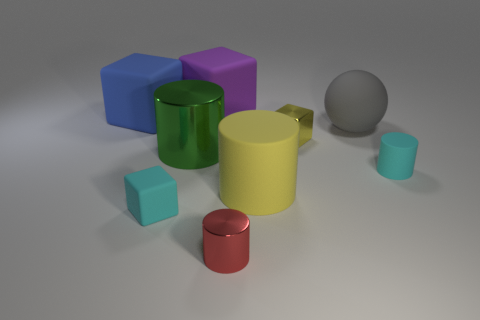Add 1 cyan blocks. How many objects exist? 10 Subtract all balls. How many objects are left? 8 Add 9 tiny yellow shiny cubes. How many tiny yellow shiny cubes are left? 10 Add 8 big matte balls. How many big matte balls exist? 9 Subtract 1 green cylinders. How many objects are left? 8 Subtract all purple things. Subtract all large balls. How many objects are left? 7 